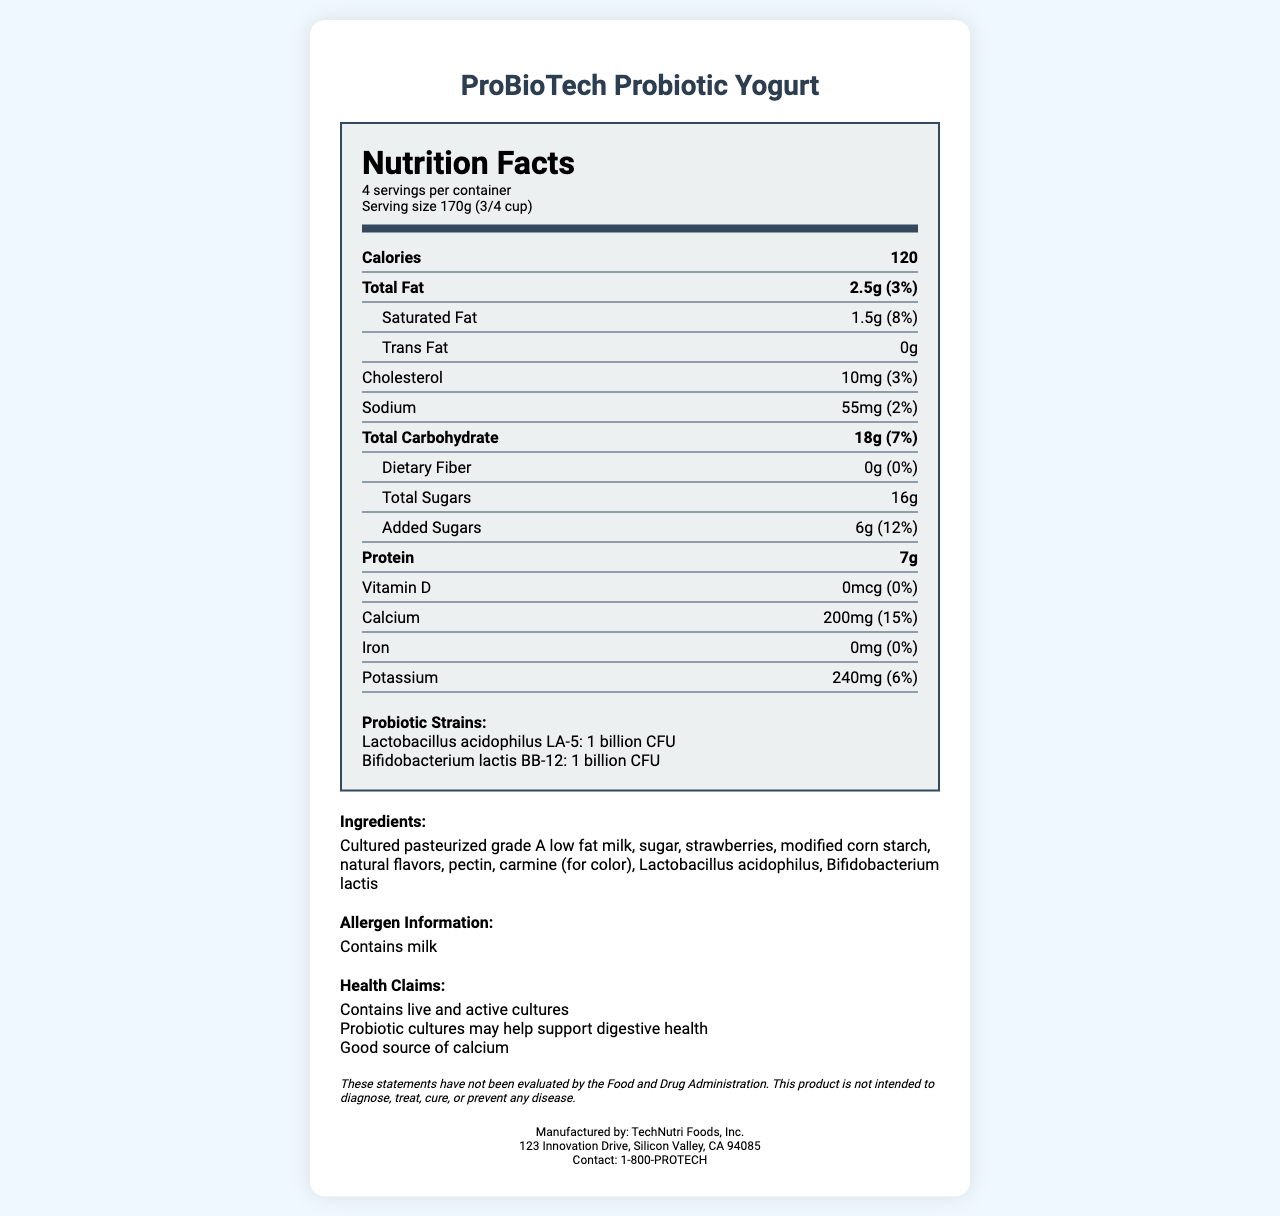What is the serving size of ProBioTech Probiotic Yogurt? The serving size is directly stated at the beginning of the nutrition label: "Serving size 170g (3/4 cup)".
Answer: 170g (3/4 cup) How many servings per container are there? It is clearly mentioned right after the product’s name: "4 servings per container".
Answer: 4 How many calories are in one serving? The calories per serving are listed prominently within the nutrition information: "Calories 120".
Answer: 120 What is the amount of Total Fat in one serving? The Total Fat content is mentioned as "Total Fat 2.5g (3%)" in the nutrition label.
Answer: 2.5g Which probiotic strains are included in ProBioTech Probiotic Yogurt? These strains are listed under the Probiotic Strains section: "Lactobacillus acidophilus LA-5: 1 billion CFU" and "Bifidobacterium lactis BB-12: 1 billion CFU".
Answer: Lactobacillus acidophilus LA-5 and Bifidobacterium lactis BB-12 What allergens are present in this product? This is specified in the allergen statement: "Contains milk".
Answer: Milk How much added sugar does one serving contain? The amount of added sugar is listed: "Added Sugars 6g (12%)".
Answer: 6g What is the percentage of Daily Value for Calcium? A. 0% B. 6% C. 12% D. 15% The percentage of Daily Value for calcium is stated within the nutrition information as "Calcium 200mg (15%)".
Answer: D. 15% Is this product intended to diagnose, treat, cure, or prevent any disease? The legal disclaimer states: "This product is not intended to diagnose, treat, cure, or prevent any disease".
Answer: No Summarize the entire document in one sentence. The document provides comprehensive information about ProBioTech Probiotic Yogurt’s nutritional facts, ingredients, health benefits, compliance, and manufacturer’s contact information.
Answer: ProBioTech Probiotic Yogurt is a probiotic-rich yogurt product with specific health claims, nutritional content, ingredient information, and regulatory compliance details. What is the total daily value percentage of dietary fiber in one serving? The daily value percentage for dietary fiber is listed as "Dietary Fiber 0g (0%)".
Answer: 0% Where is TechNutri Foods, Inc. located? The manufacturer’s address is provided under the manufacturer info: "123 Innovation Drive, Silicon Valley, CA 94085".
Answer: 123 Innovation Drive, Silicon Valley, CA 94085 Who is the supplier of the probiotic strains in ProBioTech Probiotic Yogurt? The document does not specify who the supplier of the probiotic strains is.
Answer: Not enough information 